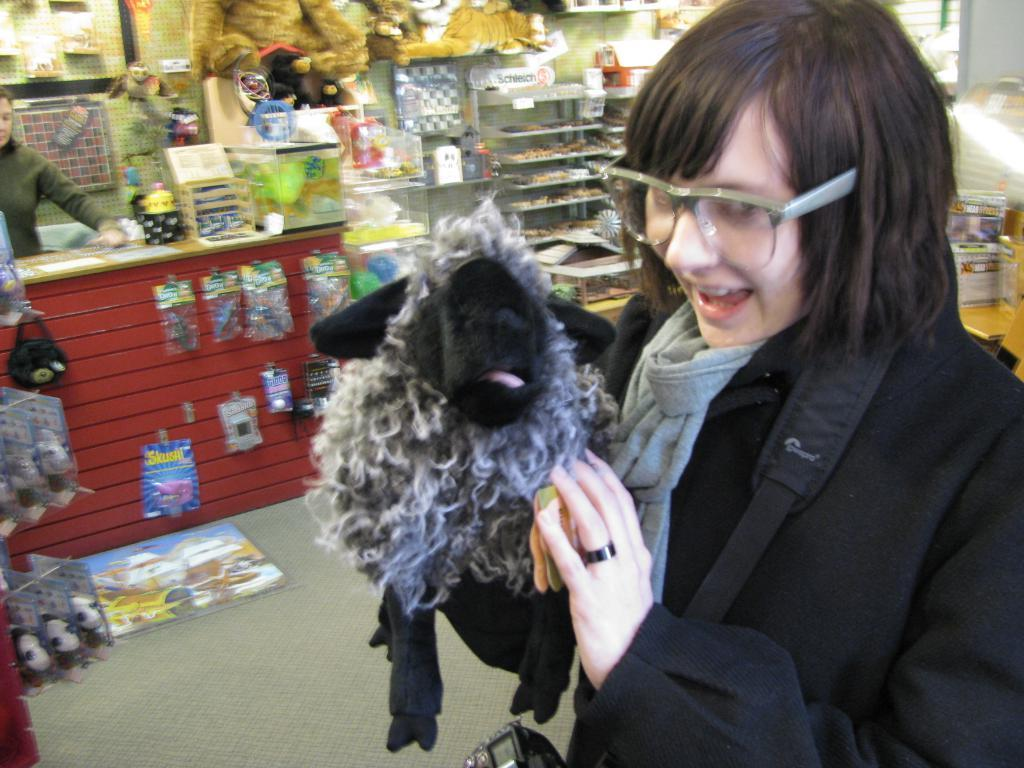Who is present in the image? There is a woman in the image. What is the woman holding in the image? The woman is holding a toy. What is the woman's expression in the image? The woman is smiling. What can be seen in the background of the image? There are various toys and dolls visible in the background of the image. What time does the watch in the image show? There is no watch present in the image. 